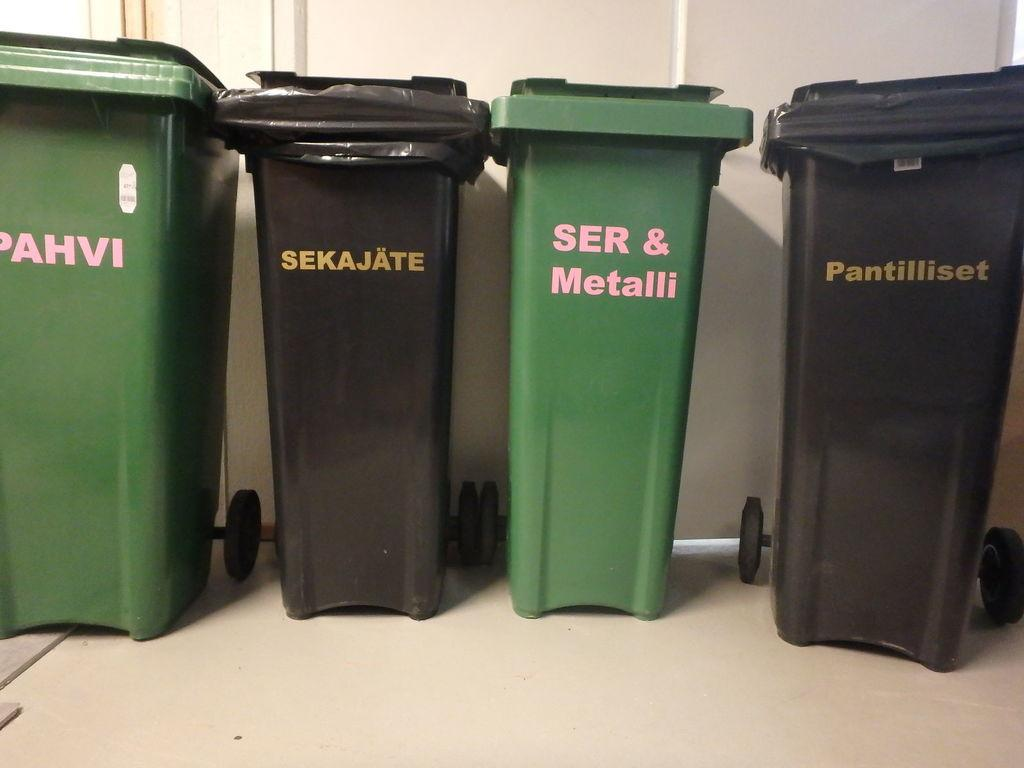Provide a one-sentence caption for the provided image. Four trash cans with words like sekajate painted on them are lined up against a wall. 